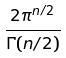<formula> <loc_0><loc_0><loc_500><loc_500>\frac { 2 \pi ^ { n / 2 } } { \Gamma ( n / 2 ) }</formula> 